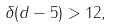Convert formula to latex. <formula><loc_0><loc_0><loc_500><loc_500>\delta ( d - 5 ) > 1 2 ,</formula> 